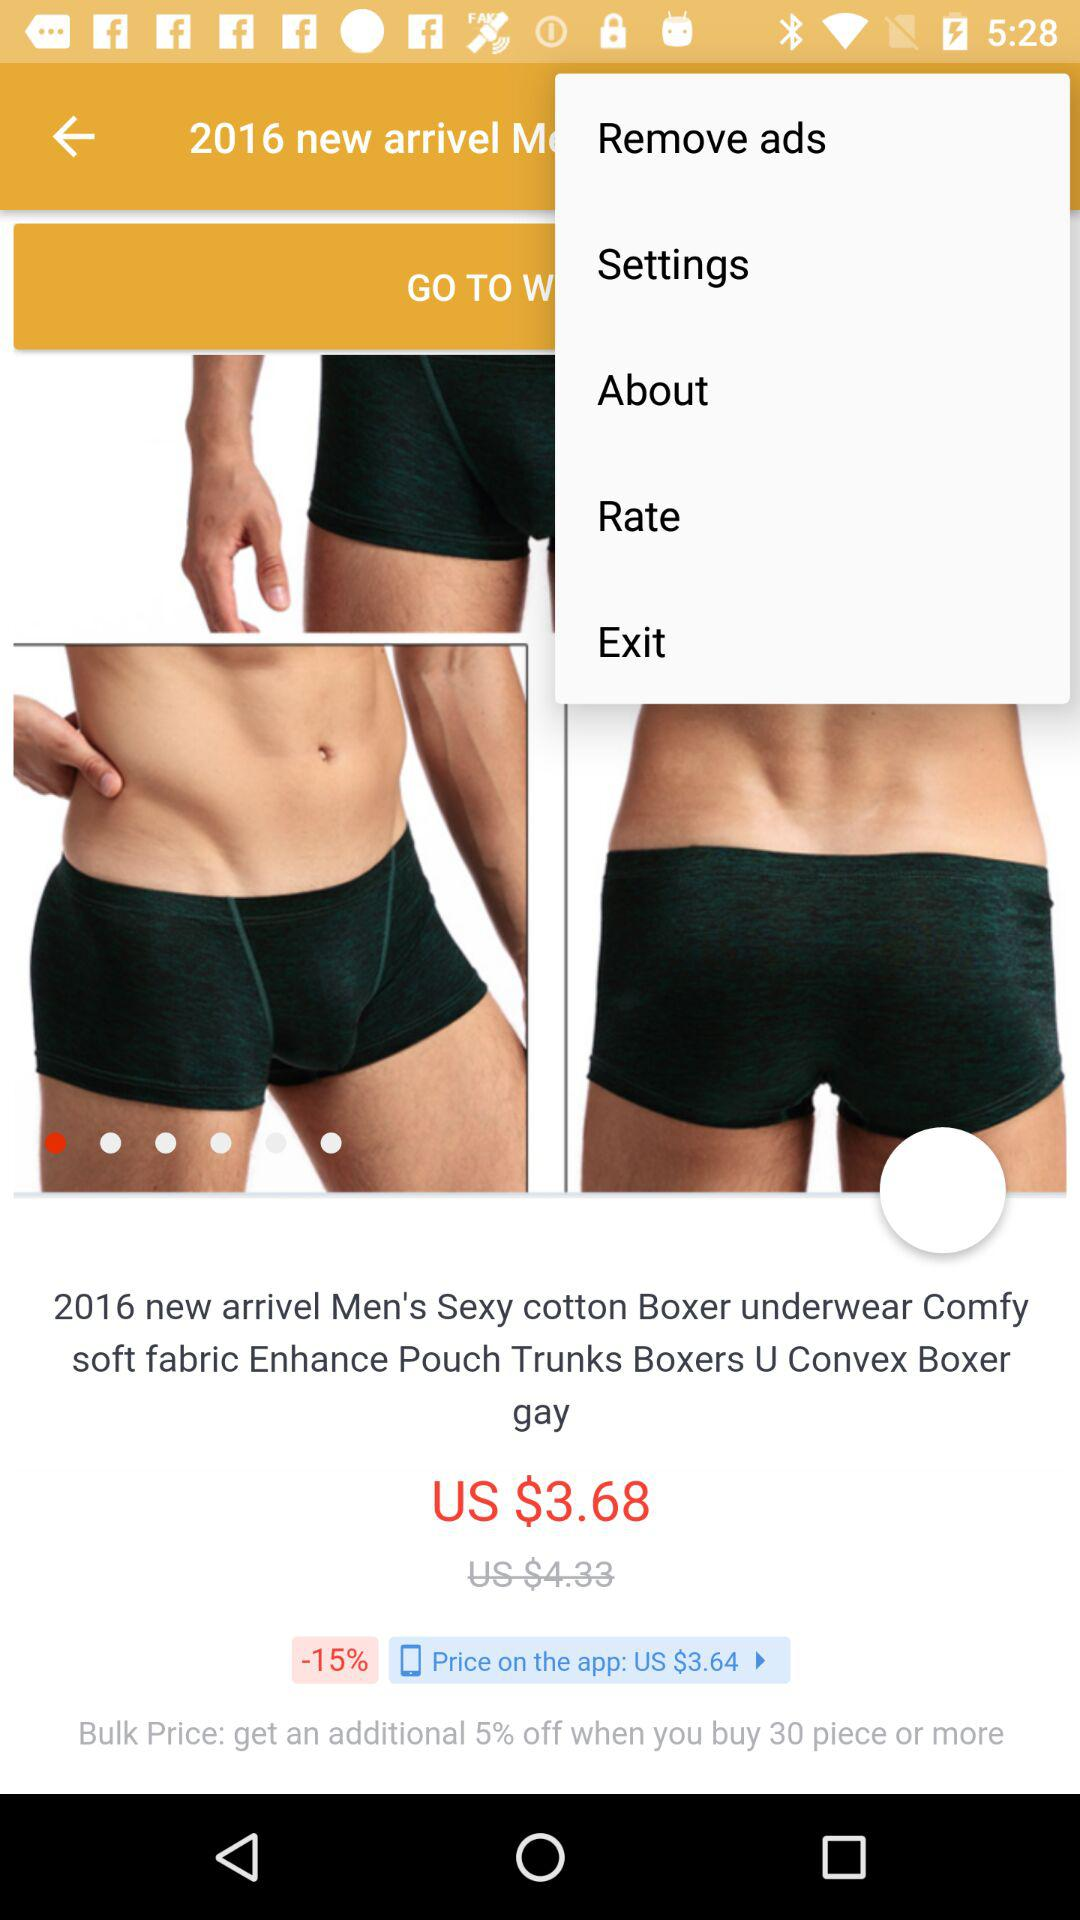What is the price of boxer underwear? The price is US $3.68. 